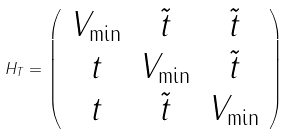<formula> <loc_0><loc_0><loc_500><loc_500>H _ { T } = \left ( \begin{array} { c c c } V _ { \min } & \tilde { t } & \tilde { t } \\ t & V _ { \min } & \tilde { t } \\ t & \tilde { t } & V _ { \min } \end{array} \right )</formula> 